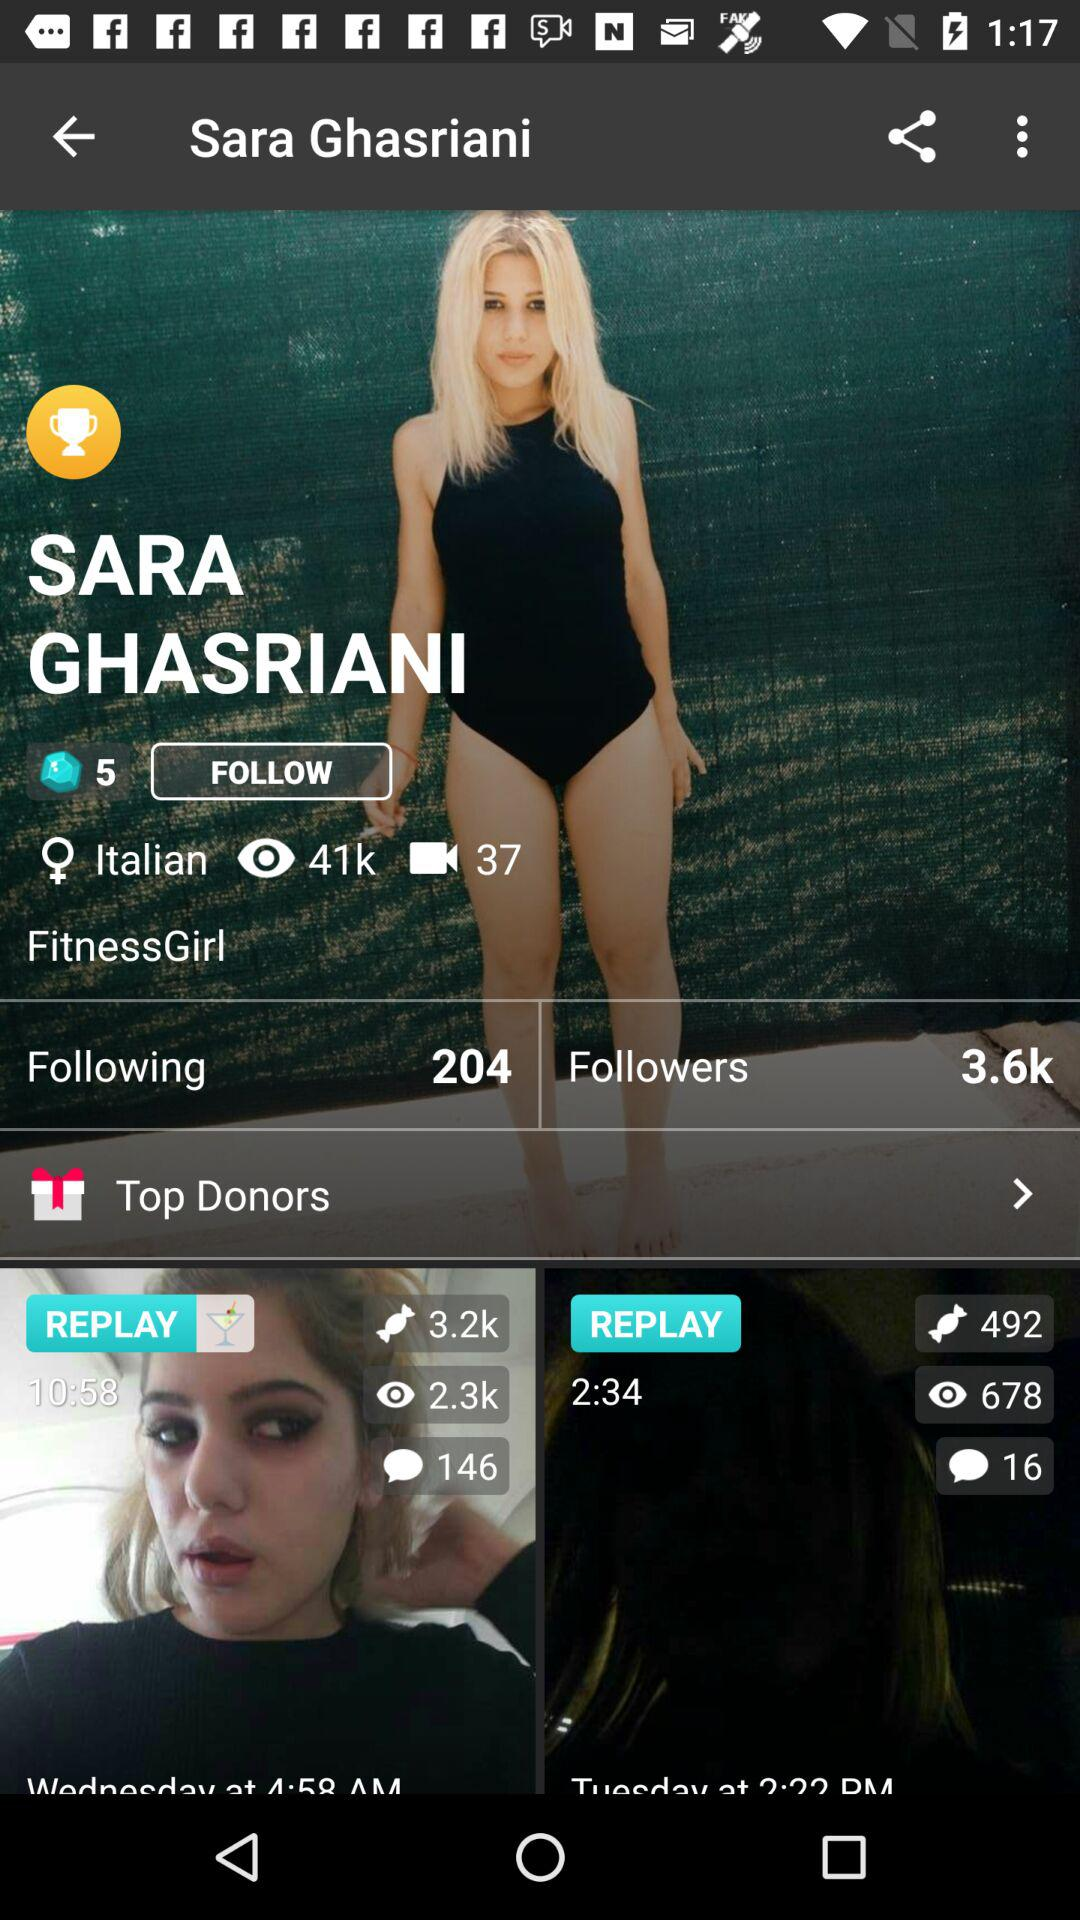What is the name of the user? The user name is Sara Ghasriani. 